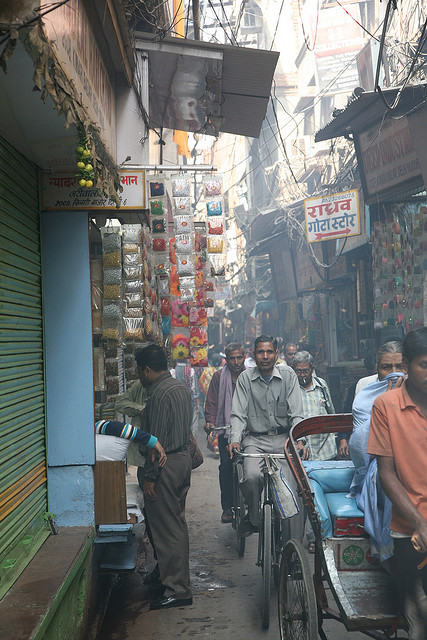<image>What language are the signs in? I don't know what language the signs are in. It could be either Chinese, Arabic, Hindi, or Japanese. What language are the signs in? I don't know what language the signs are in. They could be in Chinese, Arabic, Hindi, Japanese, or Indian. 